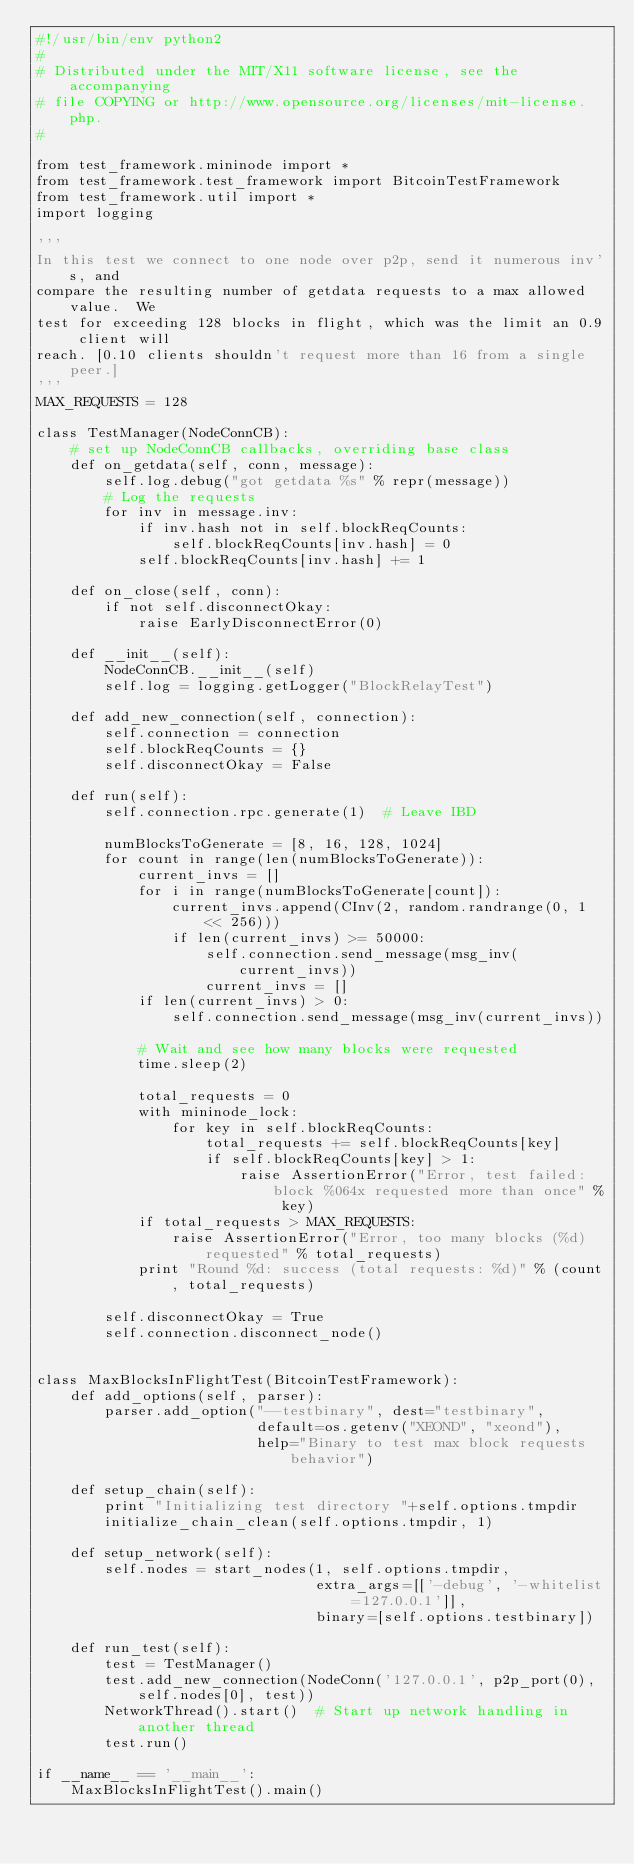Convert code to text. <code><loc_0><loc_0><loc_500><loc_500><_Python_>#!/usr/bin/env python2
#
# Distributed under the MIT/X11 software license, see the accompanying
# file COPYING or http://www.opensource.org/licenses/mit-license.php.
#

from test_framework.mininode import *
from test_framework.test_framework import BitcoinTestFramework
from test_framework.util import *
import logging

'''
In this test we connect to one node over p2p, send it numerous inv's, and
compare the resulting number of getdata requests to a max allowed value.  We
test for exceeding 128 blocks in flight, which was the limit an 0.9 client will
reach. [0.10 clients shouldn't request more than 16 from a single peer.]
'''
MAX_REQUESTS = 128

class TestManager(NodeConnCB):
    # set up NodeConnCB callbacks, overriding base class
    def on_getdata(self, conn, message):
        self.log.debug("got getdata %s" % repr(message))
        # Log the requests
        for inv in message.inv:
            if inv.hash not in self.blockReqCounts:
                self.blockReqCounts[inv.hash] = 0
            self.blockReqCounts[inv.hash] += 1

    def on_close(self, conn):
        if not self.disconnectOkay:
            raise EarlyDisconnectError(0)

    def __init__(self):
        NodeConnCB.__init__(self)
        self.log = logging.getLogger("BlockRelayTest")

    def add_new_connection(self, connection):
        self.connection = connection
        self.blockReqCounts = {}
        self.disconnectOkay = False

    def run(self):
        self.connection.rpc.generate(1)  # Leave IBD

        numBlocksToGenerate = [8, 16, 128, 1024]
        for count in range(len(numBlocksToGenerate)):
            current_invs = []
            for i in range(numBlocksToGenerate[count]):
                current_invs.append(CInv(2, random.randrange(0, 1 << 256)))
                if len(current_invs) >= 50000:
                    self.connection.send_message(msg_inv(current_invs))
                    current_invs = []
            if len(current_invs) > 0:
                self.connection.send_message(msg_inv(current_invs))

            # Wait and see how many blocks were requested
            time.sleep(2)

            total_requests = 0
            with mininode_lock:
                for key in self.blockReqCounts:
                    total_requests += self.blockReqCounts[key]
                    if self.blockReqCounts[key] > 1:
                        raise AssertionError("Error, test failed: block %064x requested more than once" % key)
            if total_requests > MAX_REQUESTS:
                raise AssertionError("Error, too many blocks (%d) requested" % total_requests)
            print "Round %d: success (total requests: %d)" % (count, total_requests)

        self.disconnectOkay = True
        self.connection.disconnect_node()


class MaxBlocksInFlightTest(BitcoinTestFramework):
    def add_options(self, parser):
        parser.add_option("--testbinary", dest="testbinary",
                          default=os.getenv("XEOND", "xeond"),
                          help="Binary to test max block requests behavior")

    def setup_chain(self):
        print "Initializing test directory "+self.options.tmpdir
        initialize_chain_clean(self.options.tmpdir, 1)

    def setup_network(self):
        self.nodes = start_nodes(1, self.options.tmpdir,
                                 extra_args=[['-debug', '-whitelist=127.0.0.1']],
                                 binary=[self.options.testbinary])

    def run_test(self):
        test = TestManager()
        test.add_new_connection(NodeConn('127.0.0.1', p2p_port(0), self.nodes[0], test))
        NetworkThread().start()  # Start up network handling in another thread
        test.run()

if __name__ == '__main__':
    MaxBlocksInFlightTest().main()
</code> 